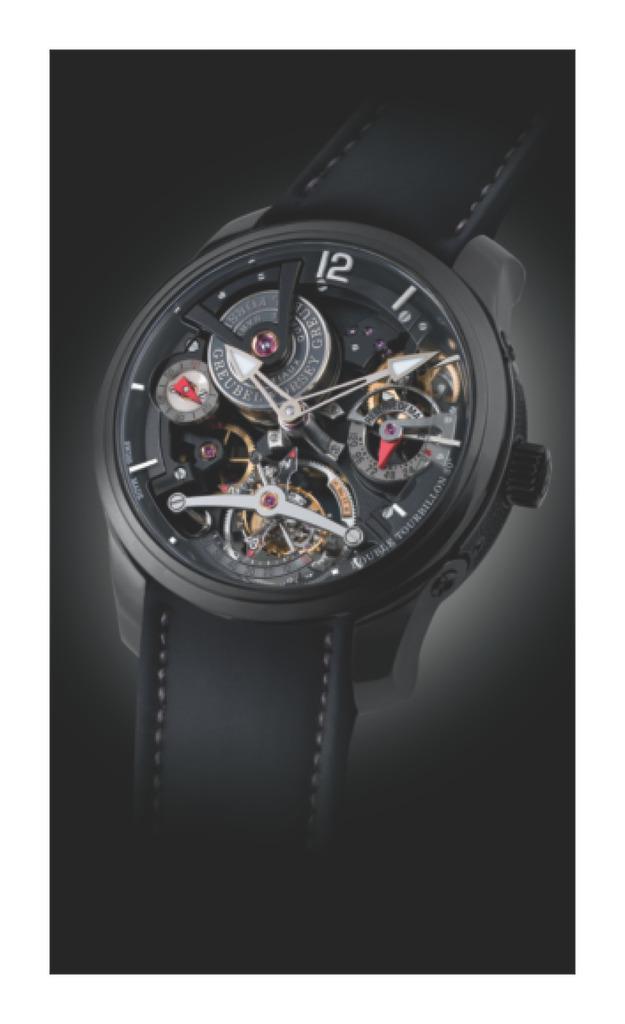Can you describe this image briefly? In the center of the image we can see a watch, which is in a black color. And we can see the dark background. 